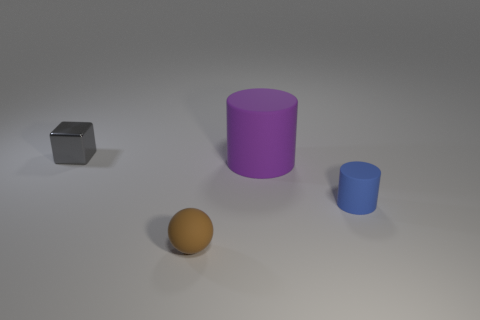Subtract all blue cylinders. How many cylinders are left? 1 Subtract all cubes. How many objects are left? 3 Subtract all yellow spheres. How many purple cylinders are left? 1 Add 4 purple things. How many objects exist? 8 Subtract all brown blocks. Subtract all yellow spheres. How many blocks are left? 1 Subtract all tiny cubes. Subtract all small shiny things. How many objects are left? 2 Add 1 small gray metallic objects. How many small gray metallic objects are left? 2 Add 3 tiny brown things. How many tiny brown things exist? 4 Subtract 0 cyan cubes. How many objects are left? 4 